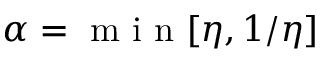Convert formula to latex. <formula><loc_0><loc_0><loc_500><loc_500>\alpha = m i n [ \eta , 1 / \eta ]</formula> 